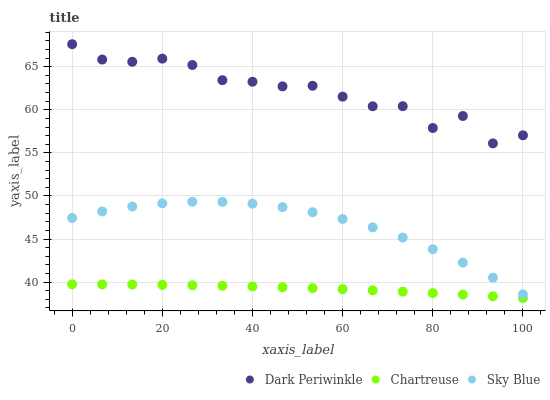Does Chartreuse have the minimum area under the curve?
Answer yes or no. Yes. Does Dark Periwinkle have the maximum area under the curve?
Answer yes or no. Yes. Does Dark Periwinkle have the minimum area under the curve?
Answer yes or no. No. Does Chartreuse have the maximum area under the curve?
Answer yes or no. No. Is Chartreuse the smoothest?
Answer yes or no. Yes. Is Dark Periwinkle the roughest?
Answer yes or no. Yes. Is Dark Periwinkle the smoothest?
Answer yes or no. No. Is Chartreuse the roughest?
Answer yes or no. No. Does Chartreuse have the lowest value?
Answer yes or no. Yes. Does Dark Periwinkle have the lowest value?
Answer yes or no. No. Does Dark Periwinkle have the highest value?
Answer yes or no. Yes. Does Chartreuse have the highest value?
Answer yes or no. No. Is Chartreuse less than Sky Blue?
Answer yes or no. Yes. Is Sky Blue greater than Chartreuse?
Answer yes or no. Yes. Does Chartreuse intersect Sky Blue?
Answer yes or no. No. 